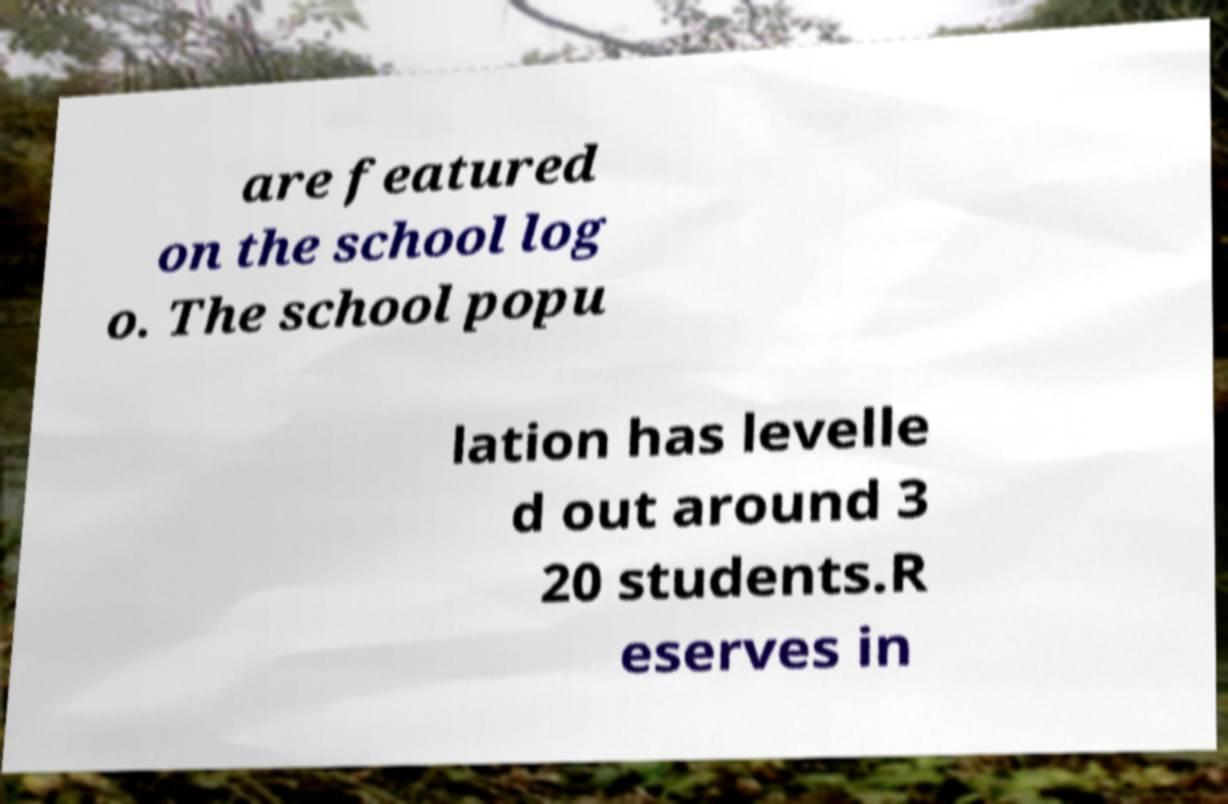For documentation purposes, I need the text within this image transcribed. Could you provide that? are featured on the school log o. The school popu lation has levelle d out around 3 20 students.R eserves in 